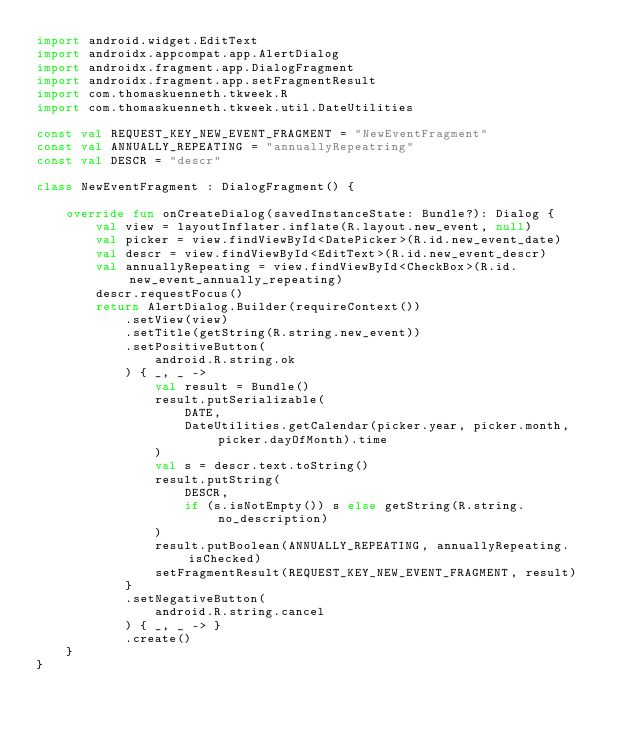<code> <loc_0><loc_0><loc_500><loc_500><_Kotlin_>import android.widget.EditText
import androidx.appcompat.app.AlertDialog
import androidx.fragment.app.DialogFragment
import androidx.fragment.app.setFragmentResult
import com.thomaskuenneth.tkweek.R
import com.thomaskuenneth.tkweek.util.DateUtilities

const val REQUEST_KEY_NEW_EVENT_FRAGMENT = "NewEventFragment"
const val ANNUALLY_REPEATING = "annuallyRepeatring"
const val DESCR = "descr"

class NewEventFragment : DialogFragment() {

    override fun onCreateDialog(savedInstanceState: Bundle?): Dialog {
        val view = layoutInflater.inflate(R.layout.new_event, null)
        val picker = view.findViewById<DatePicker>(R.id.new_event_date)
        val descr = view.findViewById<EditText>(R.id.new_event_descr)
        val annuallyRepeating = view.findViewById<CheckBox>(R.id.new_event_annually_repeating)
        descr.requestFocus()
        return AlertDialog.Builder(requireContext())
            .setView(view)
            .setTitle(getString(R.string.new_event))
            .setPositiveButton(
                android.R.string.ok
            ) { _, _ ->
                val result = Bundle()
                result.putSerializable(
                    DATE,
                    DateUtilities.getCalendar(picker.year, picker.month, picker.dayOfMonth).time
                )
                val s = descr.text.toString()
                result.putString(
                    DESCR,
                    if (s.isNotEmpty()) s else getString(R.string.no_description)
                )
                result.putBoolean(ANNUALLY_REPEATING, annuallyRepeating.isChecked)
                setFragmentResult(REQUEST_KEY_NEW_EVENT_FRAGMENT, result)
            }
            .setNegativeButton(
                android.R.string.cancel
            ) { _, _ -> }
            .create()
    }
}</code> 